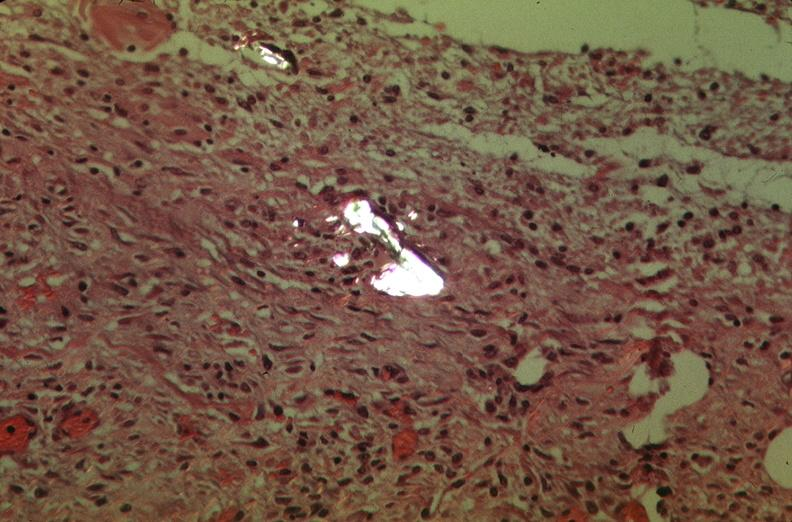was talc used to sclerose emphysematous lung, alpha-1 antitrypsin deficiency?
Answer the question using a single word or phrase. Yes 